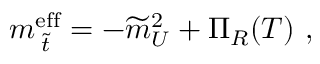Convert formula to latex. <formula><loc_0><loc_0><loc_500><loc_500>m _ { \, \widetilde { t } } ^ { e f f } = - \widetilde { m } _ { U } ^ { 2 } + \Pi _ { R } ( T ) \ ,</formula> 